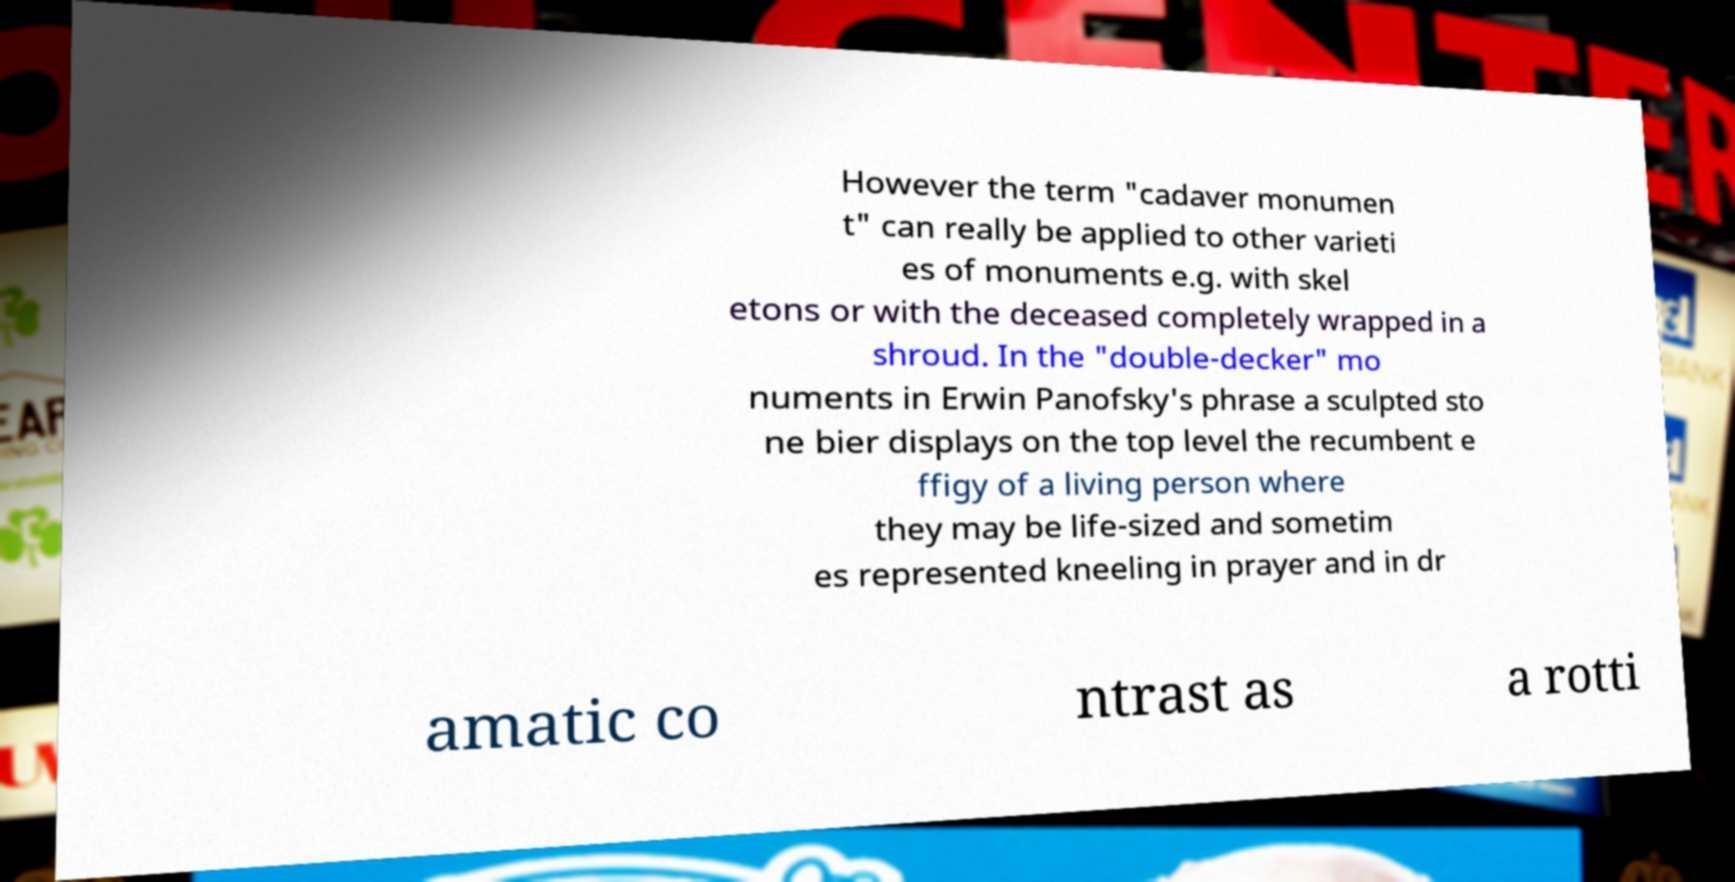Can you accurately transcribe the text from the provided image for me? However the term "cadaver monumen t" can really be applied to other varieti es of monuments e.g. with skel etons or with the deceased completely wrapped in a shroud. In the "double-decker" mo numents in Erwin Panofsky's phrase a sculpted sto ne bier displays on the top level the recumbent e ffigy of a living person where they may be life-sized and sometim es represented kneeling in prayer and in dr amatic co ntrast as a rotti 